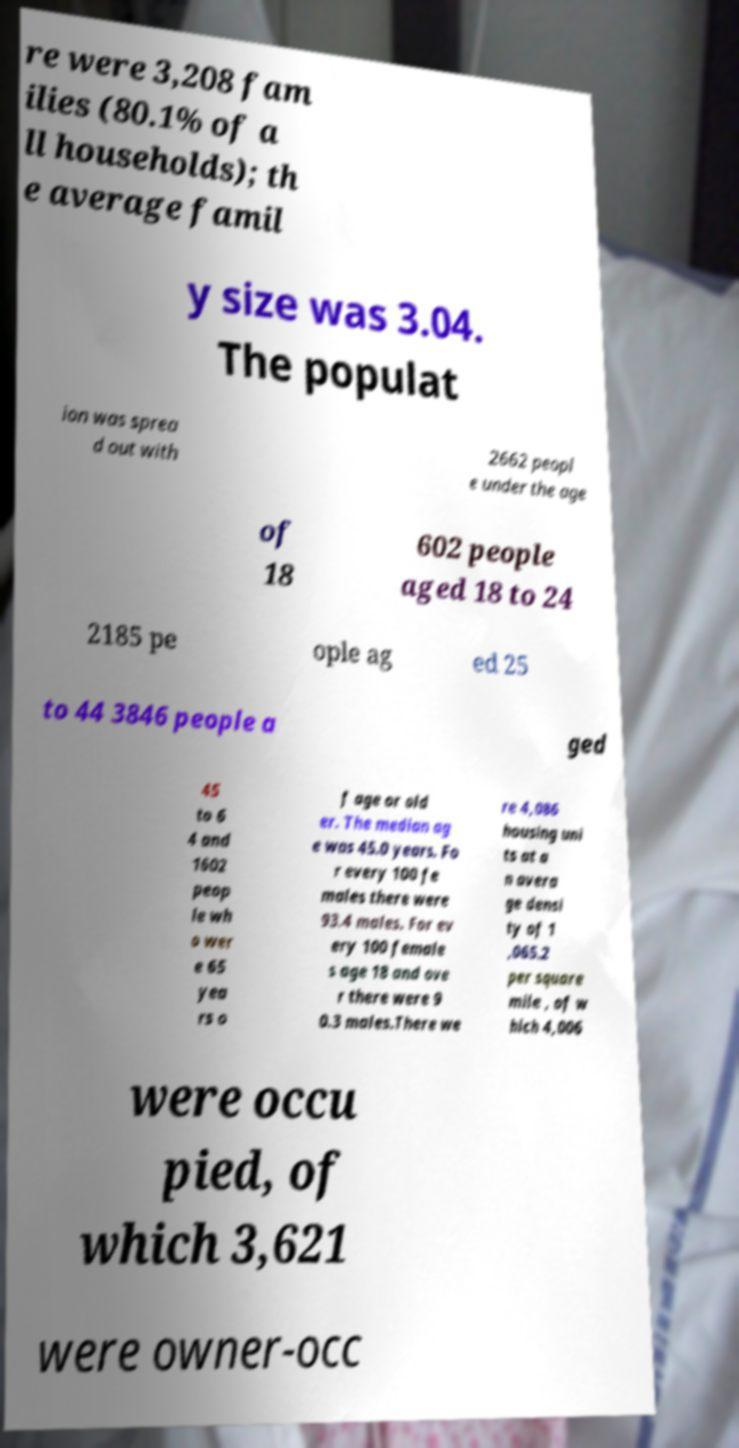Can you accurately transcribe the text from the provided image for me? re were 3,208 fam ilies (80.1% of a ll households); th e average famil y size was 3.04. The populat ion was sprea d out with 2662 peopl e under the age of 18 602 people aged 18 to 24 2185 pe ople ag ed 25 to 44 3846 people a ged 45 to 6 4 and 1602 peop le wh o wer e 65 yea rs o f age or old er. The median ag e was 45.0 years. Fo r every 100 fe males there were 93.4 males. For ev ery 100 female s age 18 and ove r there were 9 0.3 males.There we re 4,086 housing uni ts at a n avera ge densi ty of 1 ,065.2 per square mile , of w hich 4,006 were occu pied, of which 3,621 were owner-occ 